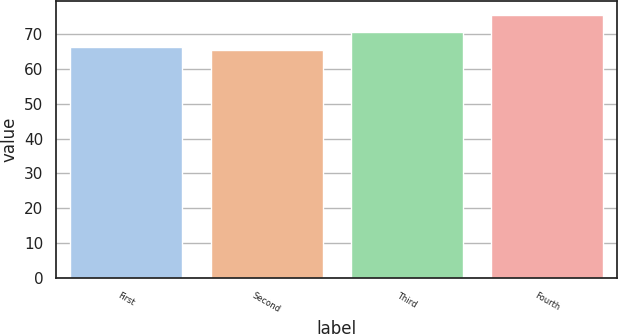Convert chart to OTSL. <chart><loc_0><loc_0><loc_500><loc_500><bar_chart><fcel>First<fcel>Second<fcel>Third<fcel>Fourth<nl><fcel>66.34<fcel>65.31<fcel>70.71<fcel>75.6<nl></chart> 